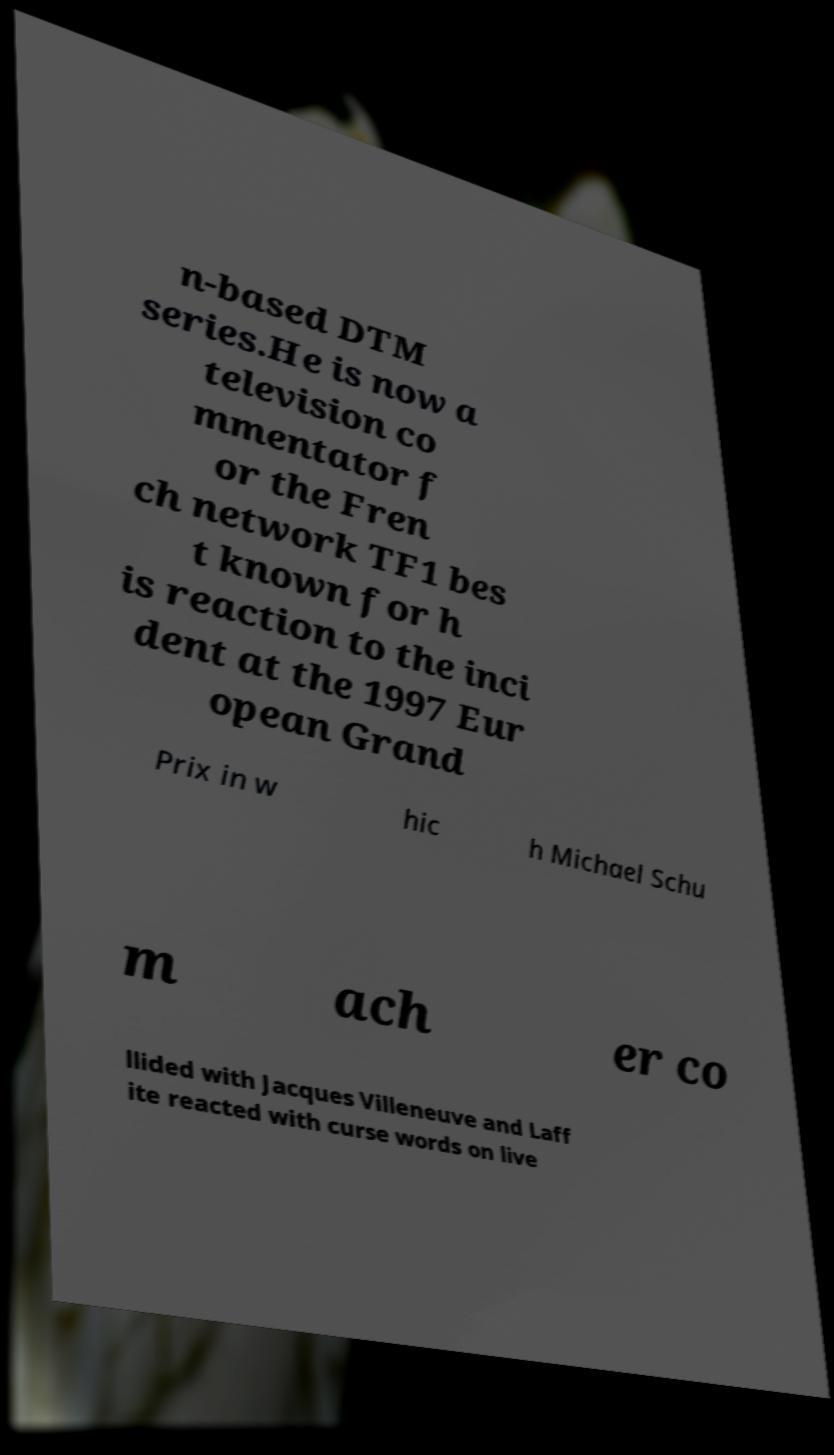Please read and relay the text visible in this image. What does it say? n-based DTM series.He is now a television co mmentator f or the Fren ch network TF1 bes t known for h is reaction to the inci dent at the 1997 Eur opean Grand Prix in w hic h Michael Schu m ach er co llided with Jacques Villeneuve and Laff ite reacted with curse words on live 